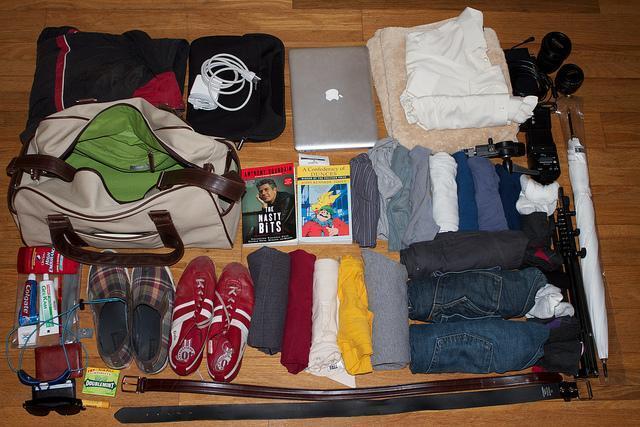How many books can be seen?
Give a very brief answer. 2. How many people are here?
Give a very brief answer. 0. 